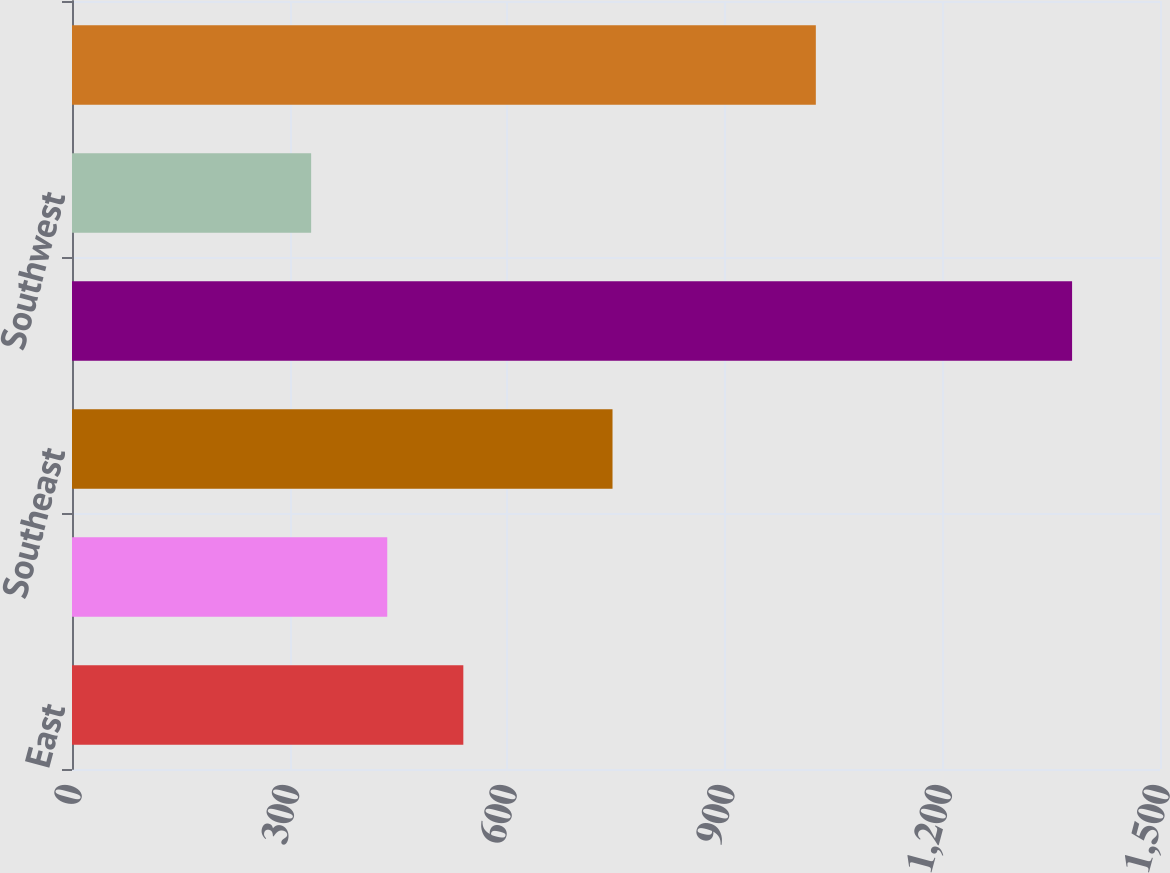<chart> <loc_0><loc_0><loc_500><loc_500><bar_chart><fcel>East<fcel>Midwest<fcel>Southeast<fcel>South Central<fcel>Southwest<fcel>West<nl><fcel>539.52<fcel>434.61<fcel>745.2<fcel>1378.8<fcel>329.7<fcel>1025.5<nl></chart> 